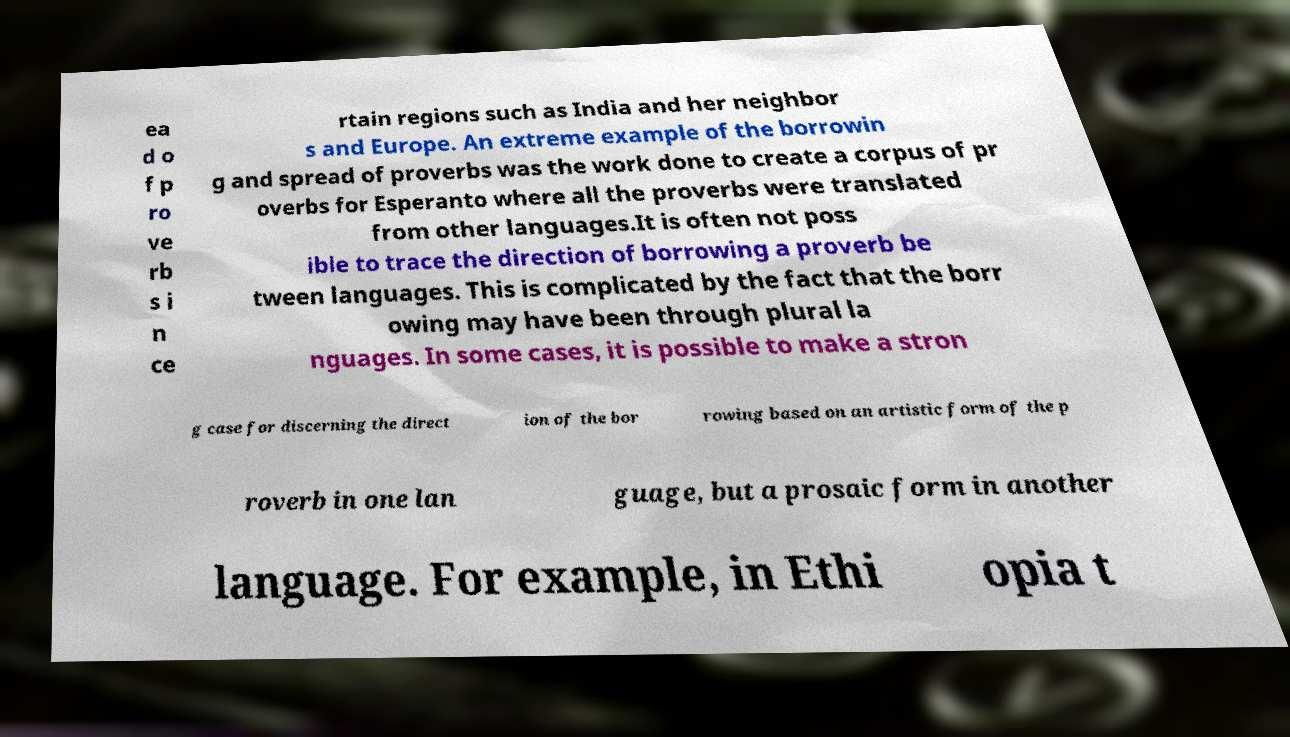For documentation purposes, I need the text within this image transcribed. Could you provide that? ea d o f p ro ve rb s i n ce rtain regions such as India and her neighbor s and Europe. An extreme example of the borrowin g and spread of proverbs was the work done to create a corpus of pr overbs for Esperanto where all the proverbs were translated from other languages.It is often not poss ible to trace the direction of borrowing a proverb be tween languages. This is complicated by the fact that the borr owing may have been through plural la nguages. In some cases, it is possible to make a stron g case for discerning the direct ion of the bor rowing based on an artistic form of the p roverb in one lan guage, but a prosaic form in another language. For example, in Ethi opia t 